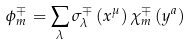<formula> <loc_0><loc_0><loc_500><loc_500>\phi ^ { \mp } _ { m } = \sum _ { \lambda } \sigma _ { \lambda } ^ { \mp } \left ( x ^ { \mu } \right ) \chi ^ { \mp } _ { m } \left ( y ^ { a } \right )</formula> 